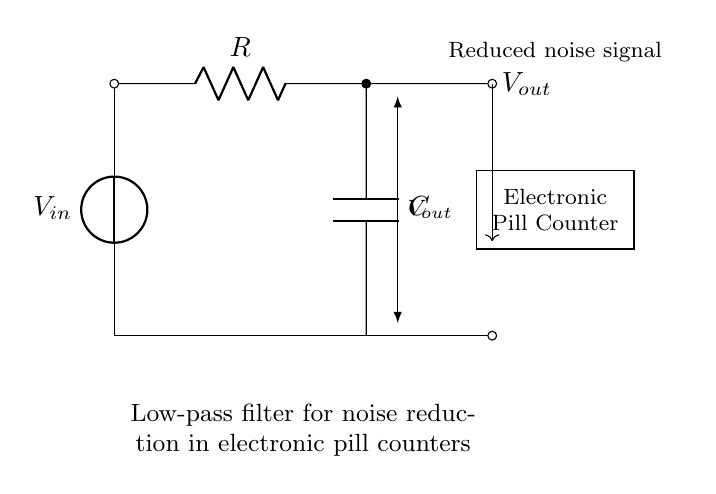What is the function of the capacitor in this circuit? The capacitor smooths out voltage fluctuations, allowing only low-frequency signals to pass through while blocking high-frequency noise. This is essential for noise reduction.
Answer: noise reduction What is the role of the resistor in this low-pass filter? The resistor works together with the capacitor to determine the cutoff frequency of the filter. It regulates the amount of current flowing through the capacitor, which influences the charging and discharging time.
Answer: determines cutoff frequency What is the output voltage labeled as in the diagram? The output voltage is labeled as Vout, which represents the voltage signal after passing through the low-pass filter circuit.
Answer: Vout What type of filter is illustrated in this circuit? The circuit is a low-pass filter, which allows low-frequency signals to pass while attenuating high-frequency signals, aiding in reducing noise levels in the electronic pill counter.
Answer: low-pass filter What component determines the cutoff frequency in this circuit? The cutoff frequency is determined by the combination of the resistor and capacitor values. The cutoff frequency can be calculated using the formula 1/(2πRC), where R is the resistance, and C is the capacitance.
Answer: resistor and capacitor How does the low-pass filter benefit the electronic pill counter? The low-pass filter reduces noise from the input signal, resulting in a cleaner output signal, which enhances the accuracy of counting pills by minimizing false counts caused by electrical noise.
Answer: cleaner output signal 